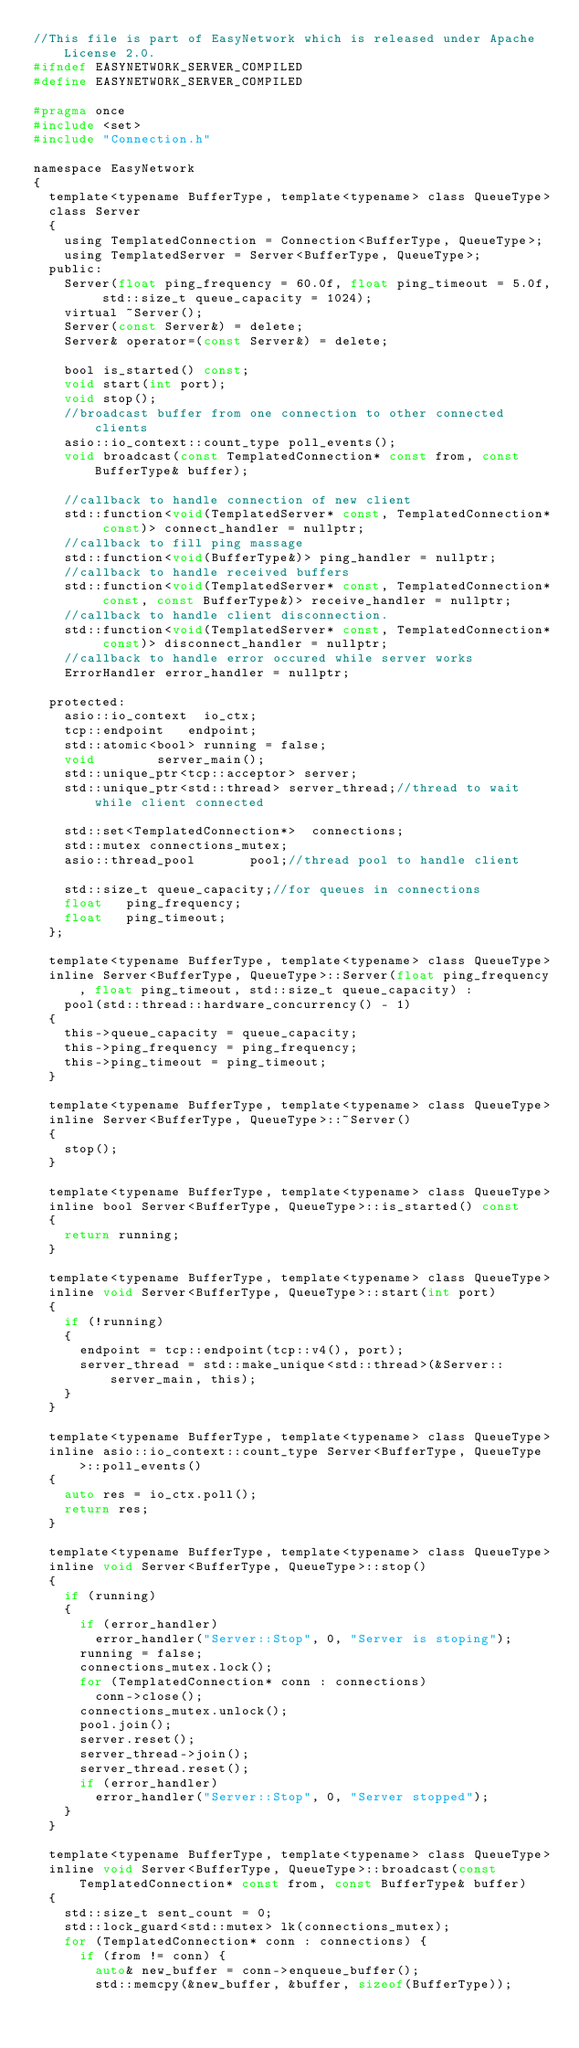<code> <loc_0><loc_0><loc_500><loc_500><_C_>//This file is part of EasyNetwork which is released under Apache License 2.0.
#ifndef EASYNETWORK_SERVER_COMPILED
#define EASYNETWORK_SERVER_COMPILED

#pragma once
#include <set>
#include "Connection.h"

namespace EasyNetwork
{
	template<typename BufferType, template<typename> class QueueType>
	class Server
	{
		using TemplatedConnection = Connection<BufferType, QueueType>;
		using TemplatedServer = Server<BufferType, QueueType>;
	public:
		Server(float ping_frequency = 60.0f, float ping_timeout = 5.0f, std::size_t queue_capacity = 1024);
		virtual ~Server();
		Server(const Server&) = delete;
		Server& operator=(const Server&) = delete;

		bool is_started() const;
		void start(int port);
		void stop();
		//broadcast buffer from one connection to other connected clients
		asio::io_context::count_type poll_events();
		void broadcast(const TemplatedConnection* const from, const BufferType& buffer);

		//callback to handle connection of new client
		std::function<void(TemplatedServer* const, TemplatedConnection* const)> connect_handler = nullptr;
		//callback to fill ping massage
		std::function<void(BufferType&)> ping_handler = nullptr;
		//callback to handle received buffers
		std::function<void(TemplatedServer* const, TemplatedConnection* const, const BufferType&)> receive_handler = nullptr;
		//callback to handle client disconnection.
		std::function<void(TemplatedServer* const, TemplatedConnection* const)> disconnect_handler = nullptr;
		//callback to handle error occured while server works
		ErrorHandler error_handler = nullptr;

	protected:
		asio::io_context	io_ctx;
		tcp::endpoint		endpoint;
		std::atomic<bool>	running = false;
		void				server_main();
		std::unique_ptr<tcp::acceptor> server;
		std::unique_ptr<std::thread> server_thread;//thread to wait while client connected

		std::set<TemplatedConnection*>	connections;
		std::mutex connections_mutex;
		asio::thread_pool				pool;//thread pool to handle client

		std::size_t queue_capacity;//for queues in connections
		float		ping_frequency;
		float		ping_timeout;
	};	

	template<typename BufferType, template<typename> class QueueType>
	inline Server<BufferType, QueueType>::Server(float ping_frequency, float ping_timeout, std::size_t queue_capacity) :
		pool(std::thread::hardware_concurrency() - 1)
	{
		this->queue_capacity = queue_capacity;
		this->ping_frequency = ping_frequency;
		this->ping_timeout = ping_timeout;
	}

	template<typename BufferType, template<typename> class QueueType>
	inline Server<BufferType, QueueType>::~Server()
	{
		stop();
	}

	template<typename BufferType, template<typename> class QueueType>
	inline bool Server<BufferType, QueueType>::is_started() const
	{
		return running;
	}

	template<typename BufferType, template<typename> class QueueType>
	inline void Server<BufferType, QueueType>::start(int port)
	{
		if (!running)
		{
			endpoint = tcp::endpoint(tcp::v4(), port);
			server_thread = std::make_unique<std::thread>(&Server::server_main, this);
		}
	}

	template<typename BufferType, template<typename> class QueueType>
	inline asio::io_context::count_type Server<BufferType, QueueType>::poll_events()
	{
		auto res = io_ctx.poll();
		return res;
	}

	template<typename BufferType, template<typename> class QueueType>
	inline void Server<BufferType, QueueType>::stop()
	{
		if (running) 
		{
			if (error_handler)
				error_handler("Server::Stop", 0, "Server is stoping");
			running = false;
			connections_mutex.lock();
			for (TemplatedConnection* conn : connections)
				conn->close();
			connections_mutex.unlock();
			pool.join();
			server.reset();
			server_thread->join();
			server_thread.reset();
			if (error_handler)
				error_handler("Server::Stop", 0, "Server stopped");
		}
	}

	template<typename BufferType, template<typename> class QueueType>
	inline void Server<BufferType, QueueType>::broadcast(const TemplatedConnection* const from, const BufferType& buffer)
	{
		std::size_t sent_count = 0;
		std::lock_guard<std::mutex> lk(connections_mutex);
		for (TemplatedConnection* conn : connections) {
			if (from != conn) {
				auto& new_buffer = conn->enqueue_buffer();
				std::memcpy(&new_buffer, &buffer, sizeof(BufferType));</code> 